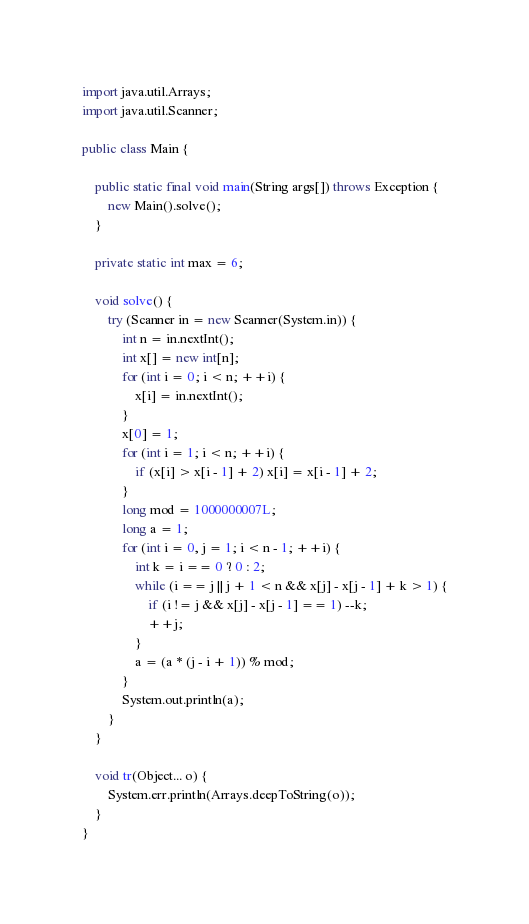<code> <loc_0><loc_0><loc_500><loc_500><_Java_>import java.util.Arrays;
import java.util.Scanner;

public class Main {

    public static final void main(String args[]) throws Exception {
        new Main().solve();
    }

    private static int max = 6;

    void solve() {
        try (Scanner in = new Scanner(System.in)) {
            int n = in.nextInt();
            int x[] = new int[n];
            for (int i = 0; i < n; ++i) {
                x[i] = in.nextInt();
            }
            x[0] = 1;
            for (int i = 1; i < n; ++i) {
                if (x[i] > x[i - 1] + 2) x[i] = x[i - 1] + 2;
            }
            long mod = 1000000007L;
            long a = 1;
            for (int i = 0, j = 1; i < n - 1; ++i) {
                int k = i == 0 ? 0 : 2;
                while (i == j || j + 1 < n && x[j] - x[j - 1] + k > 1) {
                    if (i != j && x[j] - x[j - 1] == 1) --k;
                    ++j;
                }
                a = (a * (j - i + 1)) % mod;
            }
            System.out.println(a);
        }
    }

    void tr(Object... o) {
        System.err.println(Arrays.deepToString(o));
    }
}</code> 